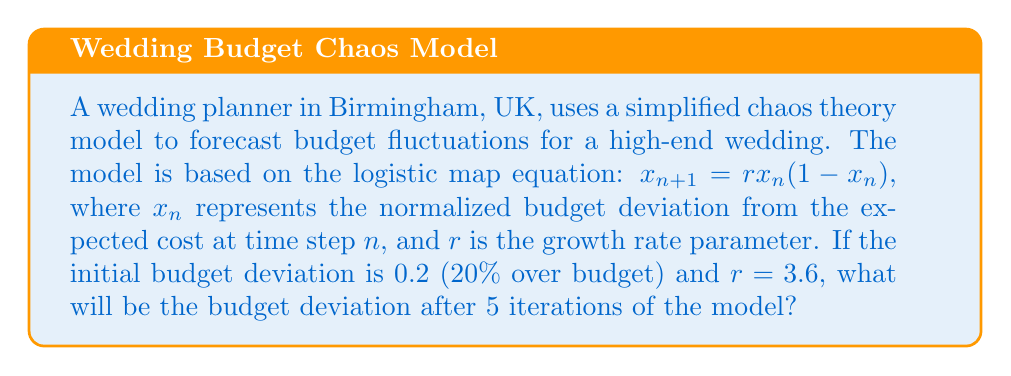Can you answer this question? To solve this problem, we need to iterate the logistic map equation 5 times, starting with the initial condition.

Given:
- Initial condition: $x_0 = 0.2$
- Growth rate parameter: $r = 3.6$
- Number of iterations: 5

Let's calculate step by step:

1. First iteration:
   $x_1 = 3.6 \cdot 0.2 \cdot (1 - 0.2) = 3.6 \cdot 0.2 \cdot 0.8 = 0.576$

2. Second iteration:
   $x_2 = 3.6 \cdot 0.576 \cdot (1 - 0.576) = 3.6 \cdot 0.576 \cdot 0.424 = 0.879706$

3. Third iteration:
   $x_3 = 3.6 \cdot 0.879706 \cdot (1 - 0.879706) = 3.6 \cdot 0.879706 \cdot 0.120294 = 0.380851$

4. Fourth iteration:
   $x_4 = 3.6 \cdot 0.380851 \cdot (1 - 0.380851) = 3.6 \cdot 0.380851 \cdot 0.619149 = 0.849576$

5. Fifth iteration:
   $x_5 = 3.6 \cdot 0.849576 \cdot (1 - 0.849576) = 3.6 \cdot 0.849576 \cdot 0.150424 = 0.460210$

The final budget deviation after 5 iterations is approximately 0.460210, or 46.0210% over budget.
Answer: 0.460210 